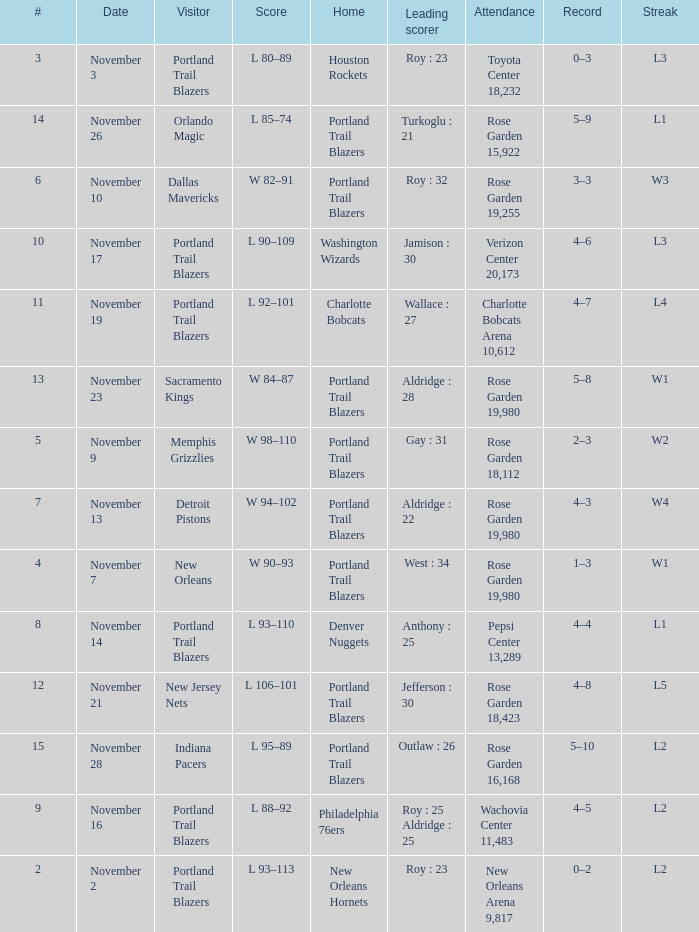Help me parse the entirety of this table. {'header': ['#', 'Date', 'Visitor', 'Score', 'Home', 'Leading scorer', 'Attendance', 'Record', 'Streak'], 'rows': [['3', 'November 3', 'Portland Trail Blazers', 'L 80–89', 'Houston Rockets', 'Roy : 23', 'Toyota Center 18,232', '0–3', 'L3'], ['14', 'November 26', 'Orlando Magic', 'L 85–74', 'Portland Trail Blazers', 'Turkoglu : 21', 'Rose Garden 15,922', '5–9', 'L1'], ['6', 'November 10', 'Dallas Mavericks', 'W 82–91', 'Portland Trail Blazers', 'Roy : 32', 'Rose Garden 19,255', '3–3', 'W3'], ['10', 'November 17', 'Portland Trail Blazers', 'L 90–109', 'Washington Wizards', 'Jamison : 30', 'Verizon Center 20,173', '4–6', 'L3'], ['11', 'November 19', 'Portland Trail Blazers', 'L 92–101', 'Charlotte Bobcats', 'Wallace : 27', 'Charlotte Bobcats Arena 10,612', '4–7', 'L4'], ['13', 'November 23', 'Sacramento Kings', 'W 84–87', 'Portland Trail Blazers', 'Aldridge : 28', 'Rose Garden 19,980', '5–8', 'W1'], ['5', 'November 9', 'Memphis Grizzlies', 'W 98–110', 'Portland Trail Blazers', 'Gay : 31', 'Rose Garden 18,112', '2–3', 'W2'], ['7', 'November 13', 'Detroit Pistons', 'W 94–102', 'Portland Trail Blazers', 'Aldridge : 22', 'Rose Garden 19,980', '4–3', 'W4'], ['4', 'November 7', 'New Orleans', 'W 90–93', 'Portland Trail Blazers', 'West : 34', 'Rose Garden 19,980', '1–3', 'W1'], ['8', 'November 14', 'Portland Trail Blazers', 'L 93–110', 'Denver Nuggets', 'Anthony : 25', 'Pepsi Center 13,289', '4–4', 'L1'], ['12', 'November 21', 'New Jersey Nets', 'L 106–101', 'Portland Trail Blazers', 'Jefferson : 30', 'Rose Garden 18,423', '4–8', 'L5'], ['15', 'November 28', 'Indiana Pacers', 'L 95–89', 'Portland Trail Blazers', 'Outlaw : 26', 'Rose Garden 16,168', '5–10', 'L2'], ['9', 'November 16', 'Portland Trail Blazers', 'L 88–92', 'Philadelphia 76ers', 'Roy : 25 Aldridge : 25', 'Wachovia Center 11,483', '4–5', 'L2'], ['2', 'November 2', 'Portland Trail Blazers', 'L 93–113', 'New Orleans Hornets', 'Roy : 23', 'New Orleans Arena 9,817', '0–2', 'L2']]}  what's the home team where streak is l3 and leading scorer is roy : 23 Houston Rockets. 